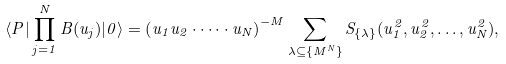Convert formula to latex. <formula><loc_0><loc_0><loc_500><loc_500>\langle P | \prod _ { j = 1 } ^ { N } B ( u _ { j } ) | 0 \rangle = \left ( u _ { 1 } u _ { 2 } \cdot \dots \cdot u _ { N } \right ) ^ { - M } \sum _ { \lambda \subseteq \{ M ^ { N } \} } S _ { \{ \lambda \} } ( u _ { 1 } ^ { 2 } , u _ { 2 } ^ { 2 } , \dots , u _ { N } ^ { 2 } ) ,</formula> 